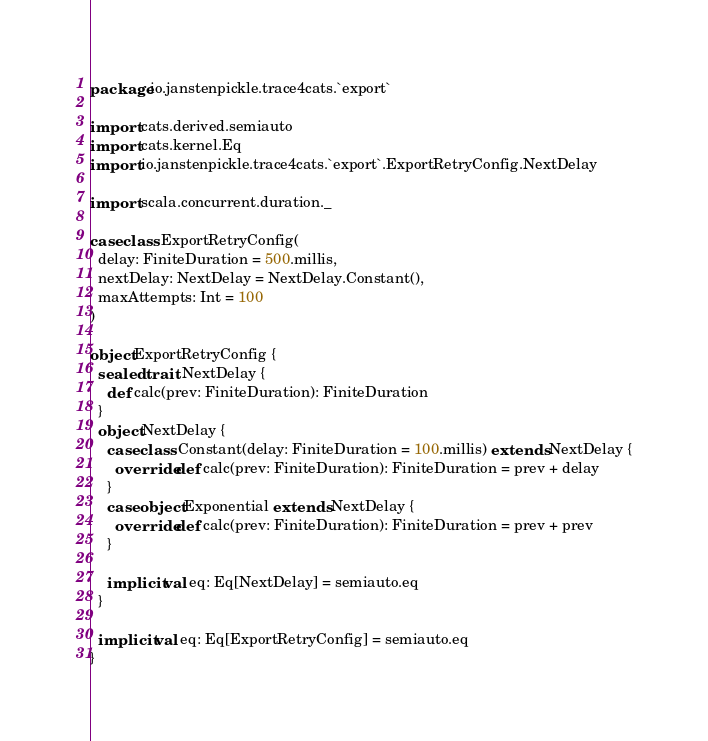<code> <loc_0><loc_0><loc_500><loc_500><_Scala_>package io.janstenpickle.trace4cats.`export`

import cats.derived.semiauto
import cats.kernel.Eq
import io.janstenpickle.trace4cats.`export`.ExportRetryConfig.NextDelay

import scala.concurrent.duration._

case class ExportRetryConfig(
  delay: FiniteDuration = 500.millis,
  nextDelay: NextDelay = NextDelay.Constant(),
  maxAttempts: Int = 100
)

object ExportRetryConfig {
  sealed trait NextDelay {
    def calc(prev: FiniteDuration): FiniteDuration
  }
  object NextDelay {
    case class Constant(delay: FiniteDuration = 100.millis) extends NextDelay {
      override def calc(prev: FiniteDuration): FiniteDuration = prev + delay
    }
    case object Exponential extends NextDelay {
      override def calc(prev: FiniteDuration): FiniteDuration = prev + prev
    }

    implicit val eq: Eq[NextDelay] = semiauto.eq
  }

  implicit val eq: Eq[ExportRetryConfig] = semiauto.eq
}
</code> 